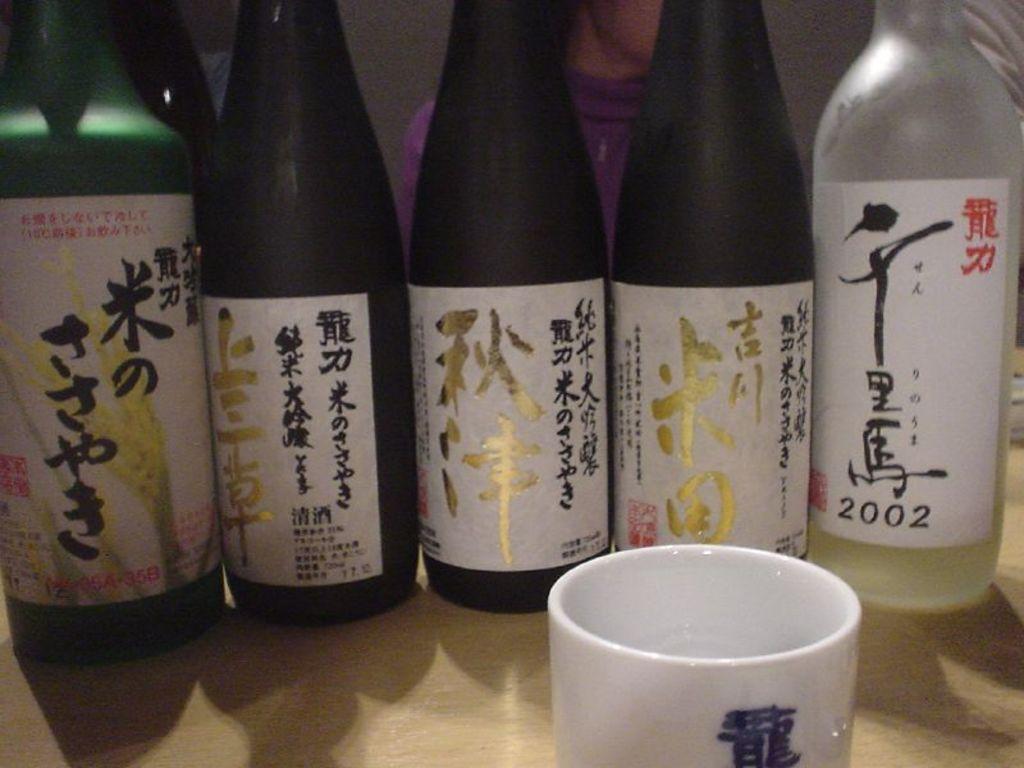What year vintage is the sake on the far right?
Provide a succinct answer. 2002. 